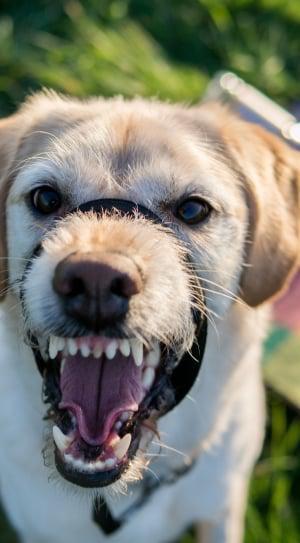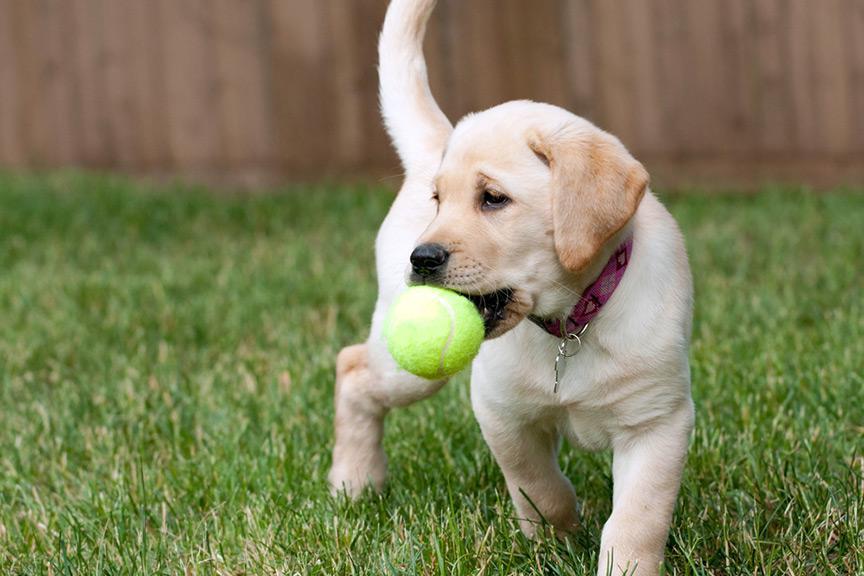The first image is the image on the left, the second image is the image on the right. Examine the images to the left and right. Is the description "An image shows an upright yellow lab baring its fangs, but not wearing any collar or muzzle." accurate? Answer yes or no. No. The first image is the image on the left, the second image is the image on the right. Analyze the images presented: Is the assertion "One of the images contains a puppy." valid? Answer yes or no. Yes. 